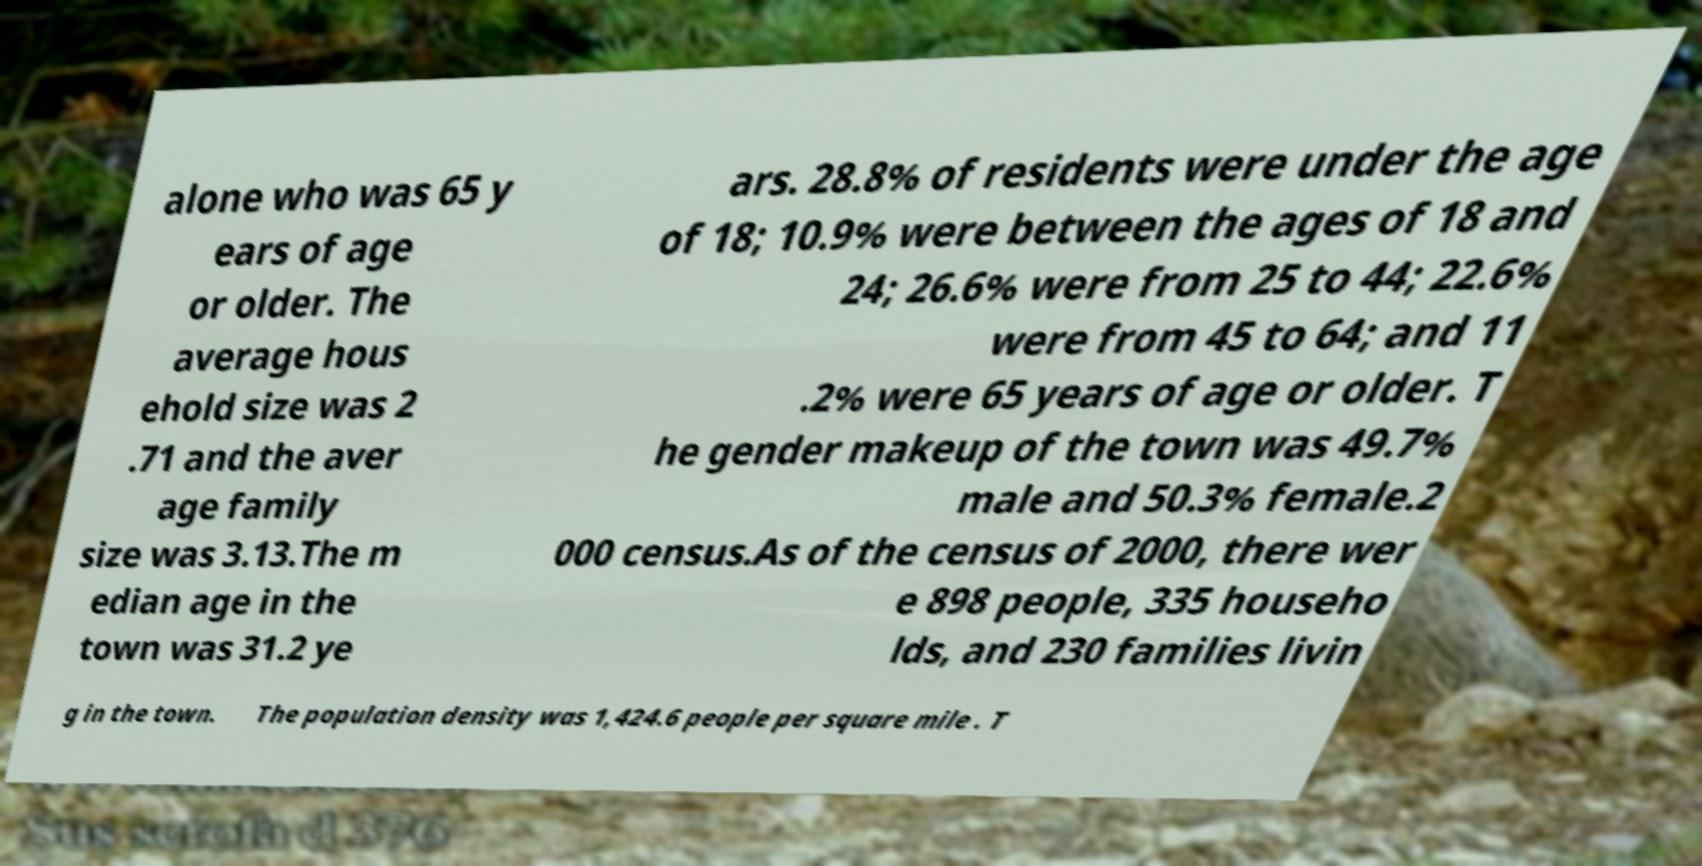Could you assist in decoding the text presented in this image and type it out clearly? alone who was 65 y ears of age or older. The average hous ehold size was 2 .71 and the aver age family size was 3.13.The m edian age in the town was 31.2 ye ars. 28.8% of residents were under the age of 18; 10.9% were between the ages of 18 and 24; 26.6% were from 25 to 44; 22.6% were from 45 to 64; and 11 .2% were 65 years of age or older. T he gender makeup of the town was 49.7% male and 50.3% female.2 000 census.As of the census of 2000, there wer e 898 people, 335 househo lds, and 230 families livin g in the town. The population density was 1,424.6 people per square mile . T 